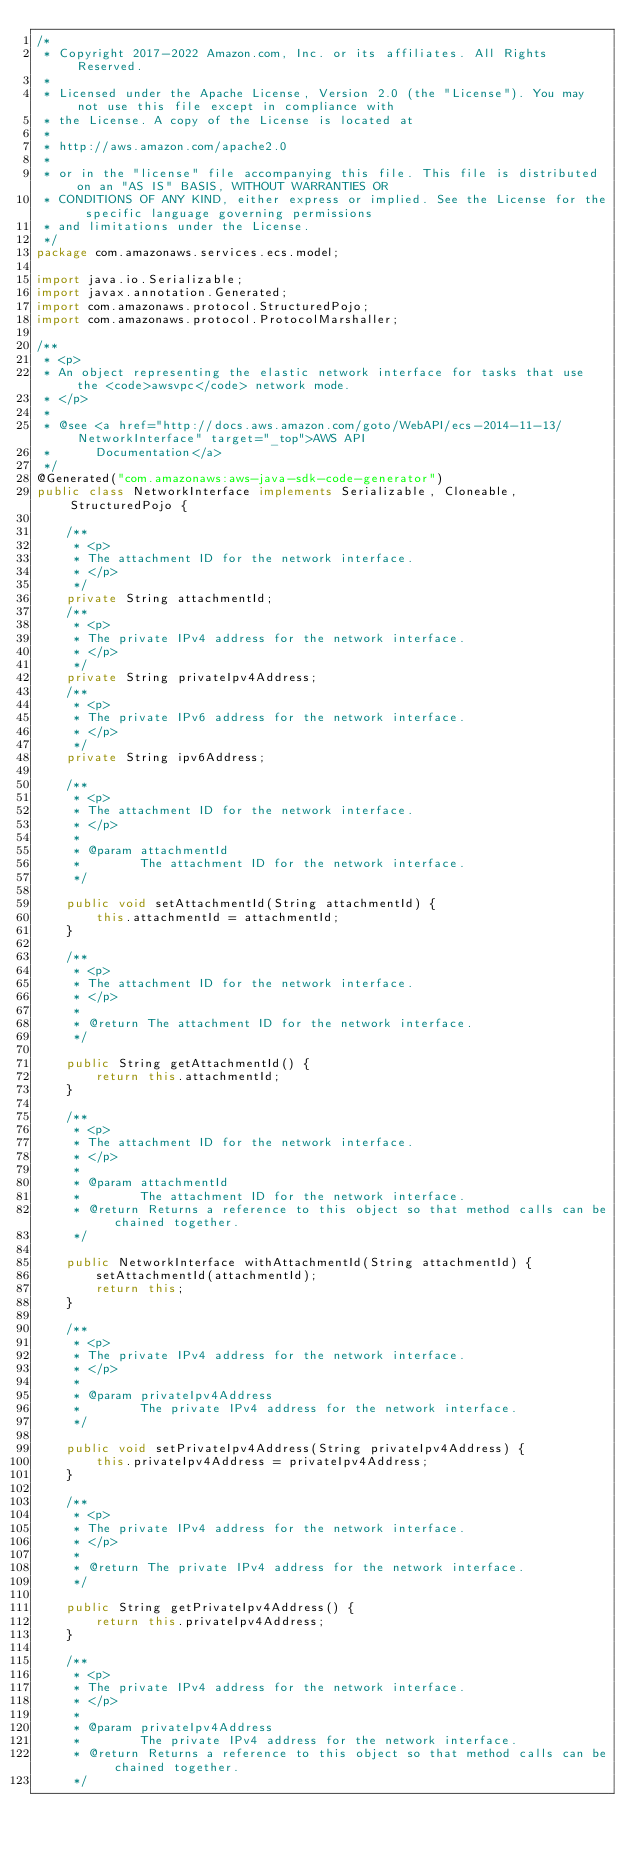<code> <loc_0><loc_0><loc_500><loc_500><_Java_>/*
 * Copyright 2017-2022 Amazon.com, Inc. or its affiliates. All Rights Reserved.
 * 
 * Licensed under the Apache License, Version 2.0 (the "License"). You may not use this file except in compliance with
 * the License. A copy of the License is located at
 * 
 * http://aws.amazon.com/apache2.0
 * 
 * or in the "license" file accompanying this file. This file is distributed on an "AS IS" BASIS, WITHOUT WARRANTIES OR
 * CONDITIONS OF ANY KIND, either express or implied. See the License for the specific language governing permissions
 * and limitations under the License.
 */
package com.amazonaws.services.ecs.model;

import java.io.Serializable;
import javax.annotation.Generated;
import com.amazonaws.protocol.StructuredPojo;
import com.amazonaws.protocol.ProtocolMarshaller;

/**
 * <p>
 * An object representing the elastic network interface for tasks that use the <code>awsvpc</code> network mode.
 * </p>
 * 
 * @see <a href="http://docs.aws.amazon.com/goto/WebAPI/ecs-2014-11-13/NetworkInterface" target="_top">AWS API
 *      Documentation</a>
 */
@Generated("com.amazonaws:aws-java-sdk-code-generator")
public class NetworkInterface implements Serializable, Cloneable, StructuredPojo {

    /**
     * <p>
     * The attachment ID for the network interface.
     * </p>
     */
    private String attachmentId;
    /**
     * <p>
     * The private IPv4 address for the network interface.
     * </p>
     */
    private String privateIpv4Address;
    /**
     * <p>
     * The private IPv6 address for the network interface.
     * </p>
     */
    private String ipv6Address;

    /**
     * <p>
     * The attachment ID for the network interface.
     * </p>
     * 
     * @param attachmentId
     *        The attachment ID for the network interface.
     */

    public void setAttachmentId(String attachmentId) {
        this.attachmentId = attachmentId;
    }

    /**
     * <p>
     * The attachment ID for the network interface.
     * </p>
     * 
     * @return The attachment ID for the network interface.
     */

    public String getAttachmentId() {
        return this.attachmentId;
    }

    /**
     * <p>
     * The attachment ID for the network interface.
     * </p>
     * 
     * @param attachmentId
     *        The attachment ID for the network interface.
     * @return Returns a reference to this object so that method calls can be chained together.
     */

    public NetworkInterface withAttachmentId(String attachmentId) {
        setAttachmentId(attachmentId);
        return this;
    }

    /**
     * <p>
     * The private IPv4 address for the network interface.
     * </p>
     * 
     * @param privateIpv4Address
     *        The private IPv4 address for the network interface.
     */

    public void setPrivateIpv4Address(String privateIpv4Address) {
        this.privateIpv4Address = privateIpv4Address;
    }

    /**
     * <p>
     * The private IPv4 address for the network interface.
     * </p>
     * 
     * @return The private IPv4 address for the network interface.
     */

    public String getPrivateIpv4Address() {
        return this.privateIpv4Address;
    }

    /**
     * <p>
     * The private IPv4 address for the network interface.
     * </p>
     * 
     * @param privateIpv4Address
     *        The private IPv4 address for the network interface.
     * @return Returns a reference to this object so that method calls can be chained together.
     */
</code> 